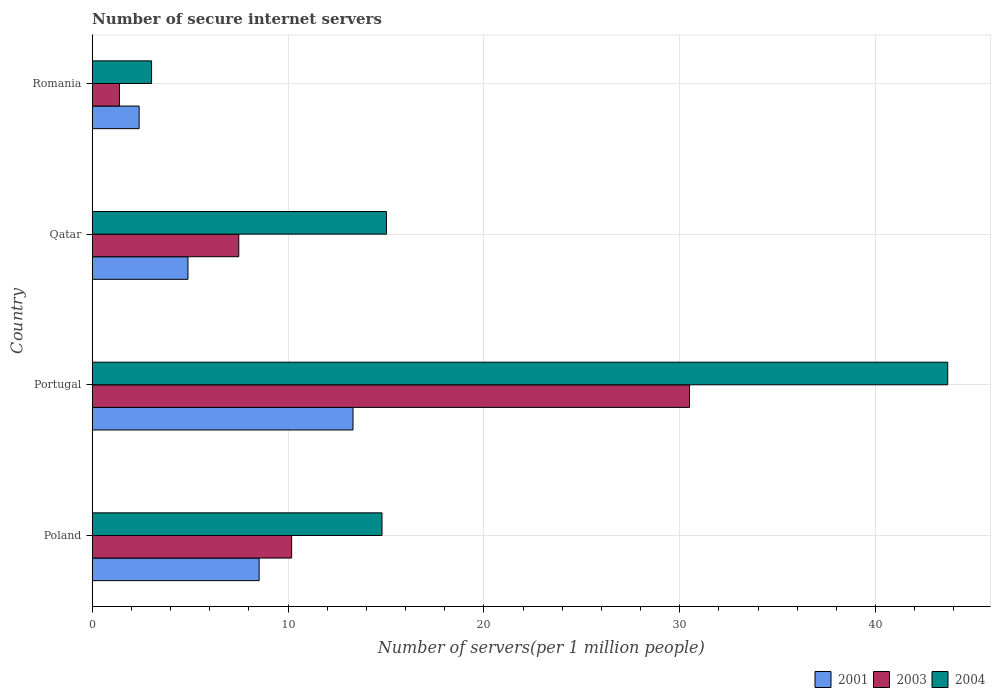How many different coloured bars are there?
Keep it short and to the point. 3. What is the label of the 2nd group of bars from the top?
Your answer should be compact. Qatar. What is the number of secure internet servers in 2001 in Romania?
Provide a short and direct response. 2.39. Across all countries, what is the maximum number of secure internet servers in 2001?
Your response must be concise. 13.32. Across all countries, what is the minimum number of secure internet servers in 2003?
Your answer should be very brief. 1.39. In which country was the number of secure internet servers in 2004 minimum?
Give a very brief answer. Romania. What is the total number of secure internet servers in 2003 in the graph?
Provide a succinct answer. 49.56. What is the difference between the number of secure internet servers in 2003 in Portugal and that in Qatar?
Your answer should be very brief. 23.02. What is the difference between the number of secure internet servers in 2004 in Romania and the number of secure internet servers in 2001 in Portugal?
Keep it short and to the point. -10.29. What is the average number of secure internet servers in 2004 per country?
Your answer should be compact. 19.13. What is the difference between the number of secure internet servers in 2001 and number of secure internet servers in 2004 in Portugal?
Ensure brevity in your answer.  -30.37. What is the ratio of the number of secure internet servers in 2003 in Poland to that in Romania?
Provide a short and direct response. 7.32. Is the difference between the number of secure internet servers in 2001 in Poland and Qatar greater than the difference between the number of secure internet servers in 2004 in Poland and Qatar?
Your answer should be very brief. Yes. What is the difference between the highest and the second highest number of secure internet servers in 2004?
Make the answer very short. 28.66. What is the difference between the highest and the lowest number of secure internet servers in 2003?
Provide a succinct answer. 29.11. In how many countries, is the number of secure internet servers in 2003 greater than the average number of secure internet servers in 2003 taken over all countries?
Your answer should be compact. 1. Is the sum of the number of secure internet servers in 2004 in Portugal and Qatar greater than the maximum number of secure internet servers in 2003 across all countries?
Keep it short and to the point. Yes. What does the 2nd bar from the top in Portugal represents?
Keep it short and to the point. 2003. What does the 2nd bar from the bottom in Romania represents?
Provide a succinct answer. 2003. Is it the case that in every country, the sum of the number of secure internet servers in 2001 and number of secure internet servers in 2004 is greater than the number of secure internet servers in 2003?
Make the answer very short. Yes. Are the values on the major ticks of X-axis written in scientific E-notation?
Keep it short and to the point. No. Does the graph contain any zero values?
Offer a terse response. No. Does the graph contain grids?
Your answer should be very brief. Yes. What is the title of the graph?
Your answer should be compact. Number of secure internet servers. What is the label or title of the X-axis?
Give a very brief answer. Number of servers(per 1 million people). What is the label or title of the Y-axis?
Offer a terse response. Country. What is the Number of servers(per 1 million people) of 2001 in Poland?
Your answer should be compact. 8.52. What is the Number of servers(per 1 million people) of 2003 in Poland?
Your answer should be compact. 10.18. What is the Number of servers(per 1 million people) in 2004 in Poland?
Ensure brevity in your answer.  14.8. What is the Number of servers(per 1 million people) in 2001 in Portugal?
Ensure brevity in your answer.  13.32. What is the Number of servers(per 1 million people) in 2003 in Portugal?
Your answer should be compact. 30.5. What is the Number of servers(per 1 million people) of 2004 in Portugal?
Offer a terse response. 43.69. What is the Number of servers(per 1 million people) in 2001 in Qatar?
Give a very brief answer. 4.89. What is the Number of servers(per 1 million people) in 2003 in Qatar?
Provide a succinct answer. 7.48. What is the Number of servers(per 1 million people) of 2004 in Qatar?
Keep it short and to the point. 15.03. What is the Number of servers(per 1 million people) in 2001 in Romania?
Keep it short and to the point. 2.39. What is the Number of servers(per 1 million people) in 2003 in Romania?
Your response must be concise. 1.39. What is the Number of servers(per 1 million people) in 2004 in Romania?
Make the answer very short. 3.03. Across all countries, what is the maximum Number of servers(per 1 million people) of 2001?
Your answer should be compact. 13.32. Across all countries, what is the maximum Number of servers(per 1 million people) of 2003?
Offer a terse response. 30.5. Across all countries, what is the maximum Number of servers(per 1 million people) in 2004?
Offer a terse response. 43.69. Across all countries, what is the minimum Number of servers(per 1 million people) in 2001?
Keep it short and to the point. 2.39. Across all countries, what is the minimum Number of servers(per 1 million people) in 2003?
Your answer should be very brief. 1.39. Across all countries, what is the minimum Number of servers(per 1 million people) in 2004?
Provide a succinct answer. 3.03. What is the total Number of servers(per 1 million people) of 2001 in the graph?
Make the answer very short. 29.12. What is the total Number of servers(per 1 million people) of 2003 in the graph?
Make the answer very short. 49.56. What is the total Number of servers(per 1 million people) in 2004 in the graph?
Give a very brief answer. 76.54. What is the difference between the Number of servers(per 1 million people) in 2001 in Poland and that in Portugal?
Provide a short and direct response. -4.79. What is the difference between the Number of servers(per 1 million people) in 2003 in Poland and that in Portugal?
Your answer should be very brief. -20.32. What is the difference between the Number of servers(per 1 million people) of 2004 in Poland and that in Portugal?
Provide a succinct answer. -28.89. What is the difference between the Number of servers(per 1 million people) in 2001 in Poland and that in Qatar?
Offer a very short reply. 3.64. What is the difference between the Number of servers(per 1 million people) of 2003 in Poland and that in Qatar?
Offer a terse response. 2.7. What is the difference between the Number of servers(per 1 million people) in 2004 in Poland and that in Qatar?
Offer a terse response. -0.23. What is the difference between the Number of servers(per 1 million people) in 2001 in Poland and that in Romania?
Provide a succinct answer. 6.13. What is the difference between the Number of servers(per 1 million people) in 2003 in Poland and that in Romania?
Provide a succinct answer. 8.79. What is the difference between the Number of servers(per 1 million people) in 2004 in Poland and that in Romania?
Your response must be concise. 11.77. What is the difference between the Number of servers(per 1 million people) in 2001 in Portugal and that in Qatar?
Ensure brevity in your answer.  8.43. What is the difference between the Number of servers(per 1 million people) in 2003 in Portugal and that in Qatar?
Offer a terse response. 23.02. What is the difference between the Number of servers(per 1 million people) of 2004 in Portugal and that in Qatar?
Provide a succinct answer. 28.66. What is the difference between the Number of servers(per 1 million people) in 2001 in Portugal and that in Romania?
Provide a short and direct response. 10.92. What is the difference between the Number of servers(per 1 million people) in 2003 in Portugal and that in Romania?
Make the answer very short. 29.11. What is the difference between the Number of servers(per 1 million people) of 2004 in Portugal and that in Romania?
Keep it short and to the point. 40.66. What is the difference between the Number of servers(per 1 million people) in 2001 in Qatar and that in Romania?
Ensure brevity in your answer.  2.49. What is the difference between the Number of servers(per 1 million people) in 2003 in Qatar and that in Romania?
Offer a terse response. 6.09. What is the difference between the Number of servers(per 1 million people) of 2004 in Qatar and that in Romania?
Your answer should be compact. 12. What is the difference between the Number of servers(per 1 million people) of 2001 in Poland and the Number of servers(per 1 million people) of 2003 in Portugal?
Provide a succinct answer. -21.98. What is the difference between the Number of servers(per 1 million people) of 2001 in Poland and the Number of servers(per 1 million people) of 2004 in Portugal?
Your response must be concise. -35.16. What is the difference between the Number of servers(per 1 million people) of 2003 in Poland and the Number of servers(per 1 million people) of 2004 in Portugal?
Your response must be concise. -33.5. What is the difference between the Number of servers(per 1 million people) of 2001 in Poland and the Number of servers(per 1 million people) of 2003 in Qatar?
Make the answer very short. 1.04. What is the difference between the Number of servers(per 1 million people) of 2001 in Poland and the Number of servers(per 1 million people) of 2004 in Qatar?
Your answer should be compact. -6.5. What is the difference between the Number of servers(per 1 million people) in 2003 in Poland and the Number of servers(per 1 million people) in 2004 in Qatar?
Provide a succinct answer. -4.84. What is the difference between the Number of servers(per 1 million people) in 2001 in Poland and the Number of servers(per 1 million people) in 2003 in Romania?
Give a very brief answer. 7.13. What is the difference between the Number of servers(per 1 million people) of 2001 in Poland and the Number of servers(per 1 million people) of 2004 in Romania?
Make the answer very short. 5.49. What is the difference between the Number of servers(per 1 million people) in 2003 in Poland and the Number of servers(per 1 million people) in 2004 in Romania?
Provide a succinct answer. 7.15. What is the difference between the Number of servers(per 1 million people) in 2001 in Portugal and the Number of servers(per 1 million people) in 2003 in Qatar?
Give a very brief answer. 5.83. What is the difference between the Number of servers(per 1 million people) of 2001 in Portugal and the Number of servers(per 1 million people) of 2004 in Qatar?
Offer a very short reply. -1.71. What is the difference between the Number of servers(per 1 million people) of 2003 in Portugal and the Number of servers(per 1 million people) of 2004 in Qatar?
Your response must be concise. 15.48. What is the difference between the Number of servers(per 1 million people) in 2001 in Portugal and the Number of servers(per 1 million people) in 2003 in Romania?
Make the answer very short. 11.93. What is the difference between the Number of servers(per 1 million people) in 2001 in Portugal and the Number of servers(per 1 million people) in 2004 in Romania?
Offer a very short reply. 10.29. What is the difference between the Number of servers(per 1 million people) in 2003 in Portugal and the Number of servers(per 1 million people) in 2004 in Romania?
Give a very brief answer. 27.47. What is the difference between the Number of servers(per 1 million people) of 2001 in Qatar and the Number of servers(per 1 million people) of 2003 in Romania?
Make the answer very short. 3.5. What is the difference between the Number of servers(per 1 million people) in 2001 in Qatar and the Number of servers(per 1 million people) in 2004 in Romania?
Keep it short and to the point. 1.86. What is the difference between the Number of servers(per 1 million people) in 2003 in Qatar and the Number of servers(per 1 million people) in 2004 in Romania?
Offer a very short reply. 4.45. What is the average Number of servers(per 1 million people) of 2001 per country?
Offer a very short reply. 7.28. What is the average Number of servers(per 1 million people) of 2003 per country?
Your answer should be compact. 12.39. What is the average Number of servers(per 1 million people) in 2004 per country?
Provide a short and direct response. 19.13. What is the difference between the Number of servers(per 1 million people) in 2001 and Number of servers(per 1 million people) in 2003 in Poland?
Your response must be concise. -1.66. What is the difference between the Number of servers(per 1 million people) of 2001 and Number of servers(per 1 million people) of 2004 in Poland?
Your response must be concise. -6.27. What is the difference between the Number of servers(per 1 million people) of 2003 and Number of servers(per 1 million people) of 2004 in Poland?
Your response must be concise. -4.62. What is the difference between the Number of servers(per 1 million people) in 2001 and Number of servers(per 1 million people) in 2003 in Portugal?
Give a very brief answer. -17.18. What is the difference between the Number of servers(per 1 million people) of 2001 and Number of servers(per 1 million people) of 2004 in Portugal?
Make the answer very short. -30.37. What is the difference between the Number of servers(per 1 million people) of 2003 and Number of servers(per 1 million people) of 2004 in Portugal?
Your response must be concise. -13.19. What is the difference between the Number of servers(per 1 million people) of 2001 and Number of servers(per 1 million people) of 2003 in Qatar?
Provide a short and direct response. -2.6. What is the difference between the Number of servers(per 1 million people) of 2001 and Number of servers(per 1 million people) of 2004 in Qatar?
Provide a short and direct response. -10.14. What is the difference between the Number of servers(per 1 million people) of 2003 and Number of servers(per 1 million people) of 2004 in Qatar?
Provide a succinct answer. -7.54. What is the difference between the Number of servers(per 1 million people) of 2001 and Number of servers(per 1 million people) of 2003 in Romania?
Provide a short and direct response. 1. What is the difference between the Number of servers(per 1 million people) of 2001 and Number of servers(per 1 million people) of 2004 in Romania?
Provide a succinct answer. -0.64. What is the difference between the Number of servers(per 1 million people) in 2003 and Number of servers(per 1 million people) in 2004 in Romania?
Make the answer very short. -1.64. What is the ratio of the Number of servers(per 1 million people) of 2001 in Poland to that in Portugal?
Provide a succinct answer. 0.64. What is the ratio of the Number of servers(per 1 million people) of 2003 in Poland to that in Portugal?
Provide a short and direct response. 0.33. What is the ratio of the Number of servers(per 1 million people) of 2004 in Poland to that in Portugal?
Your answer should be very brief. 0.34. What is the ratio of the Number of servers(per 1 million people) in 2001 in Poland to that in Qatar?
Provide a succinct answer. 1.74. What is the ratio of the Number of servers(per 1 million people) in 2003 in Poland to that in Qatar?
Provide a short and direct response. 1.36. What is the ratio of the Number of servers(per 1 million people) in 2001 in Poland to that in Romania?
Keep it short and to the point. 3.56. What is the ratio of the Number of servers(per 1 million people) in 2003 in Poland to that in Romania?
Provide a short and direct response. 7.32. What is the ratio of the Number of servers(per 1 million people) of 2004 in Poland to that in Romania?
Give a very brief answer. 4.88. What is the ratio of the Number of servers(per 1 million people) in 2001 in Portugal to that in Qatar?
Offer a very short reply. 2.72. What is the ratio of the Number of servers(per 1 million people) in 2003 in Portugal to that in Qatar?
Ensure brevity in your answer.  4.08. What is the ratio of the Number of servers(per 1 million people) of 2004 in Portugal to that in Qatar?
Provide a short and direct response. 2.91. What is the ratio of the Number of servers(per 1 million people) in 2001 in Portugal to that in Romania?
Ensure brevity in your answer.  5.56. What is the ratio of the Number of servers(per 1 million people) in 2003 in Portugal to that in Romania?
Give a very brief answer. 21.93. What is the ratio of the Number of servers(per 1 million people) of 2004 in Portugal to that in Romania?
Keep it short and to the point. 14.42. What is the ratio of the Number of servers(per 1 million people) of 2001 in Qatar to that in Romania?
Offer a terse response. 2.04. What is the ratio of the Number of servers(per 1 million people) in 2003 in Qatar to that in Romania?
Your response must be concise. 5.38. What is the ratio of the Number of servers(per 1 million people) of 2004 in Qatar to that in Romania?
Your answer should be compact. 4.96. What is the difference between the highest and the second highest Number of servers(per 1 million people) in 2001?
Offer a very short reply. 4.79. What is the difference between the highest and the second highest Number of servers(per 1 million people) of 2003?
Your response must be concise. 20.32. What is the difference between the highest and the second highest Number of servers(per 1 million people) of 2004?
Provide a short and direct response. 28.66. What is the difference between the highest and the lowest Number of servers(per 1 million people) of 2001?
Ensure brevity in your answer.  10.92. What is the difference between the highest and the lowest Number of servers(per 1 million people) in 2003?
Your answer should be very brief. 29.11. What is the difference between the highest and the lowest Number of servers(per 1 million people) in 2004?
Ensure brevity in your answer.  40.66. 